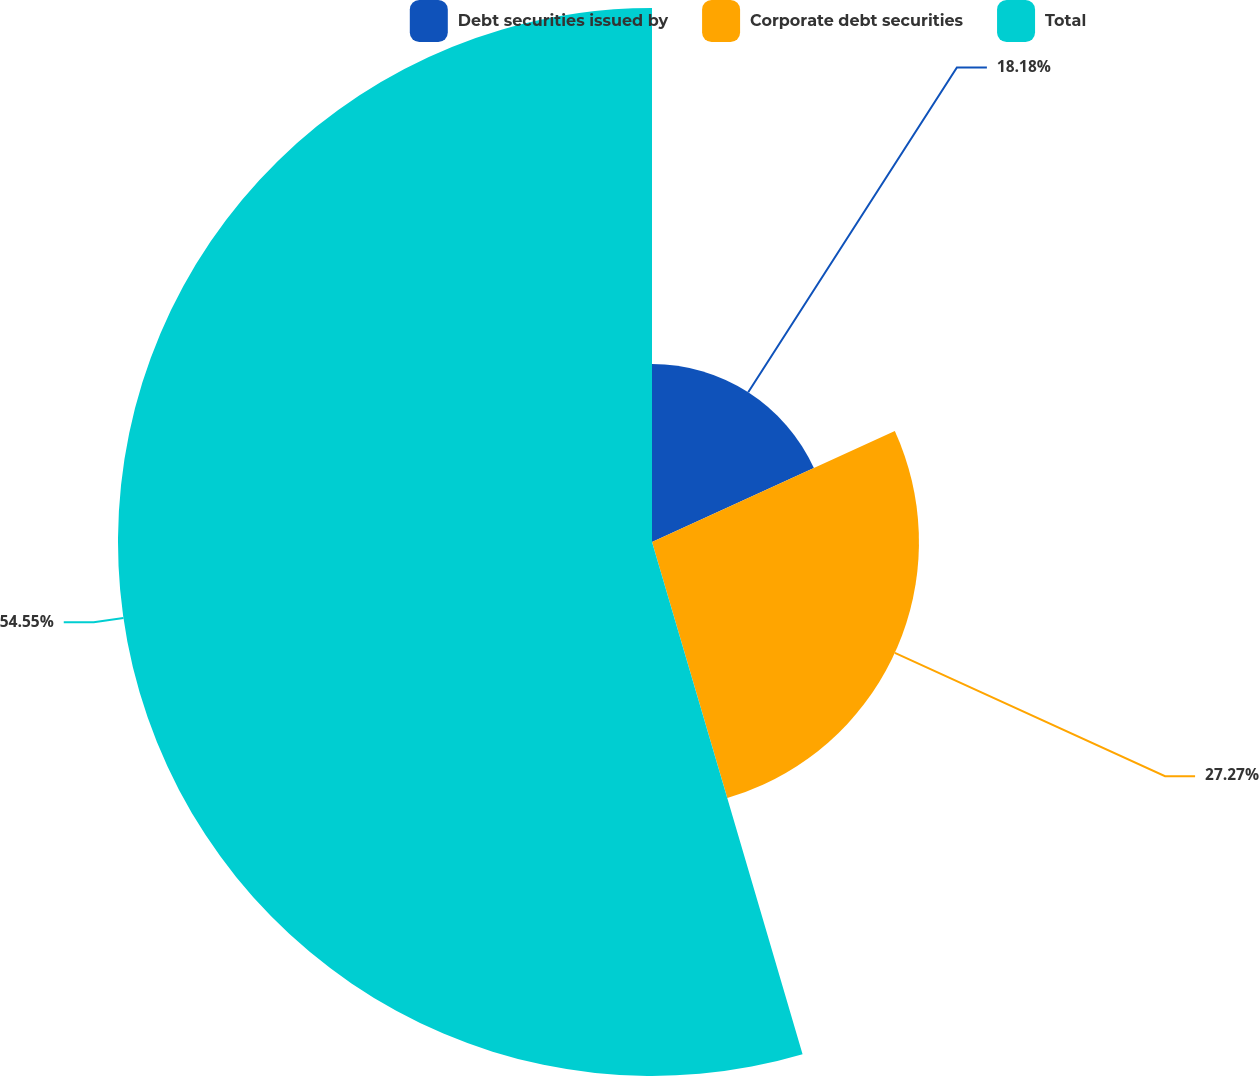Convert chart. <chart><loc_0><loc_0><loc_500><loc_500><pie_chart><fcel>Debt securities issued by<fcel>Corporate debt securities<fcel>Total<nl><fcel>18.18%<fcel>27.27%<fcel>54.55%<nl></chart> 